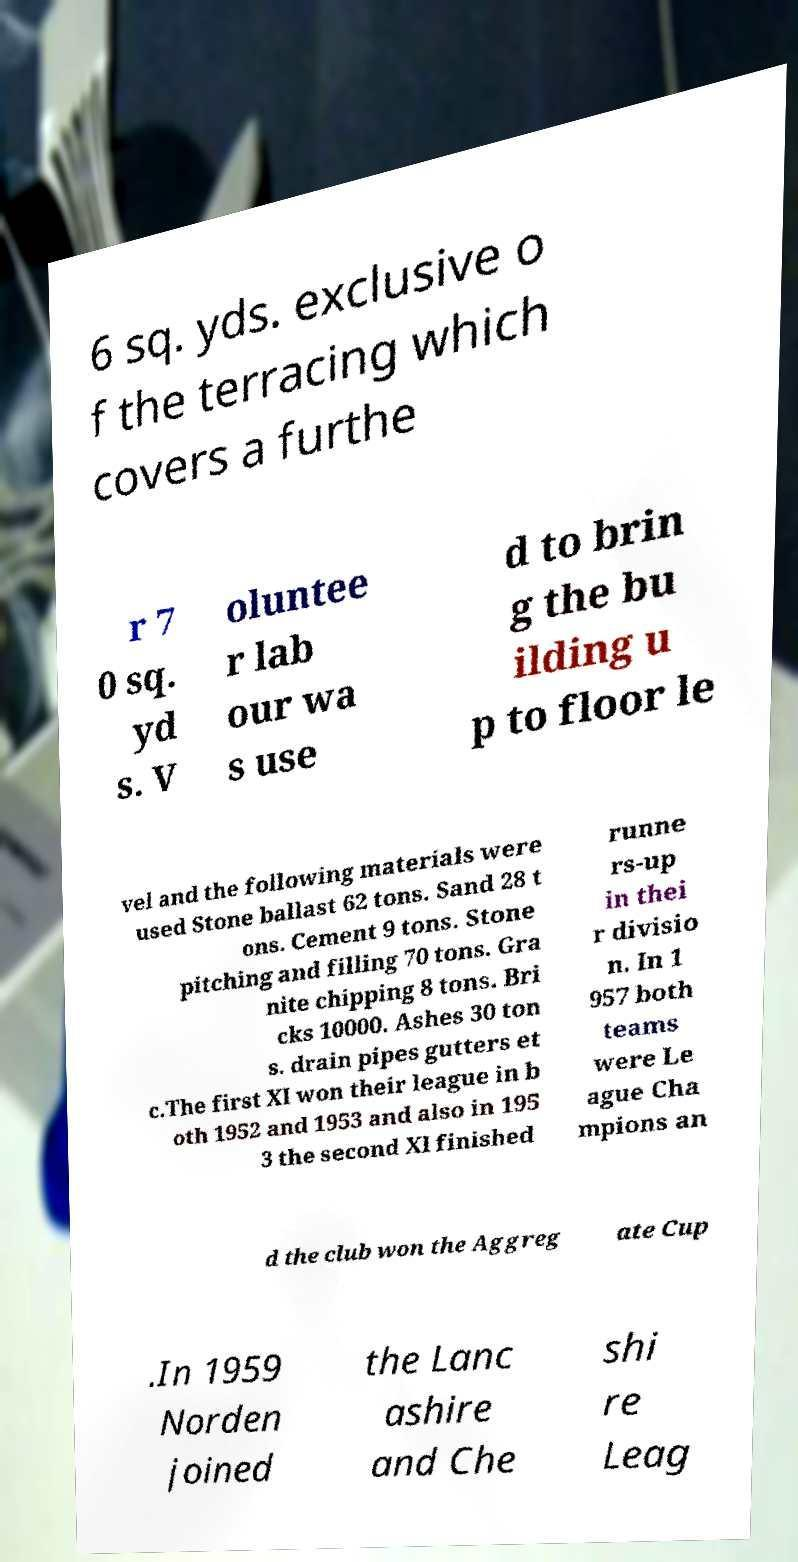Please identify and transcribe the text found in this image. 6 sq. yds. exclusive o f the terracing which covers a furthe r 7 0 sq. yd s. V oluntee r lab our wa s use d to brin g the bu ilding u p to floor le vel and the following materials were used Stone ballast 62 tons. Sand 28 t ons. Cement 9 tons. Stone pitching and filling 70 tons. Gra nite chipping 8 tons. Bri cks 10000. Ashes 30 ton s. drain pipes gutters et c.The first XI won their league in b oth 1952 and 1953 and also in 195 3 the second XI finished runne rs-up in thei r divisio n. In 1 957 both teams were Le ague Cha mpions an d the club won the Aggreg ate Cup .In 1959 Norden joined the Lanc ashire and Che shi re Leag 